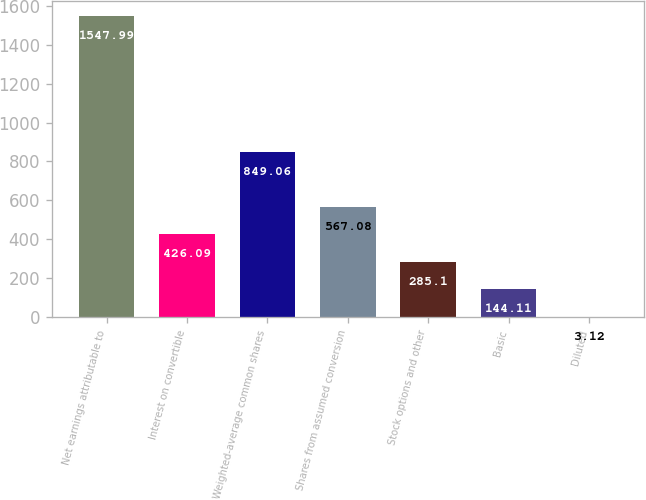<chart> <loc_0><loc_0><loc_500><loc_500><bar_chart><fcel>Net earnings attributable to<fcel>Interest on convertible<fcel>Weighted-average common shares<fcel>Shares from assumed conversion<fcel>Stock options and other<fcel>Basic<fcel>Diluted<nl><fcel>1547.99<fcel>426.09<fcel>849.06<fcel>567.08<fcel>285.1<fcel>144.11<fcel>3.12<nl></chart> 